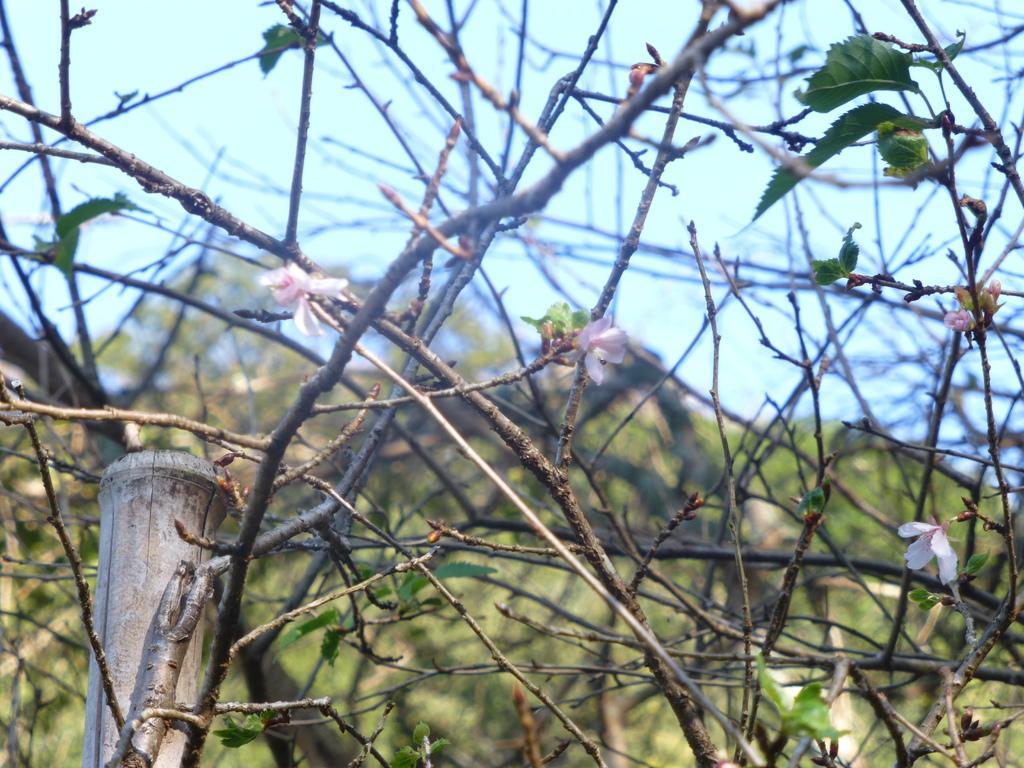How would you summarize this image in a sentence or two? In this image there are trees, there are leaves, there are flowers, there is the sky, there is an object truncated towards the bottom of the image. 